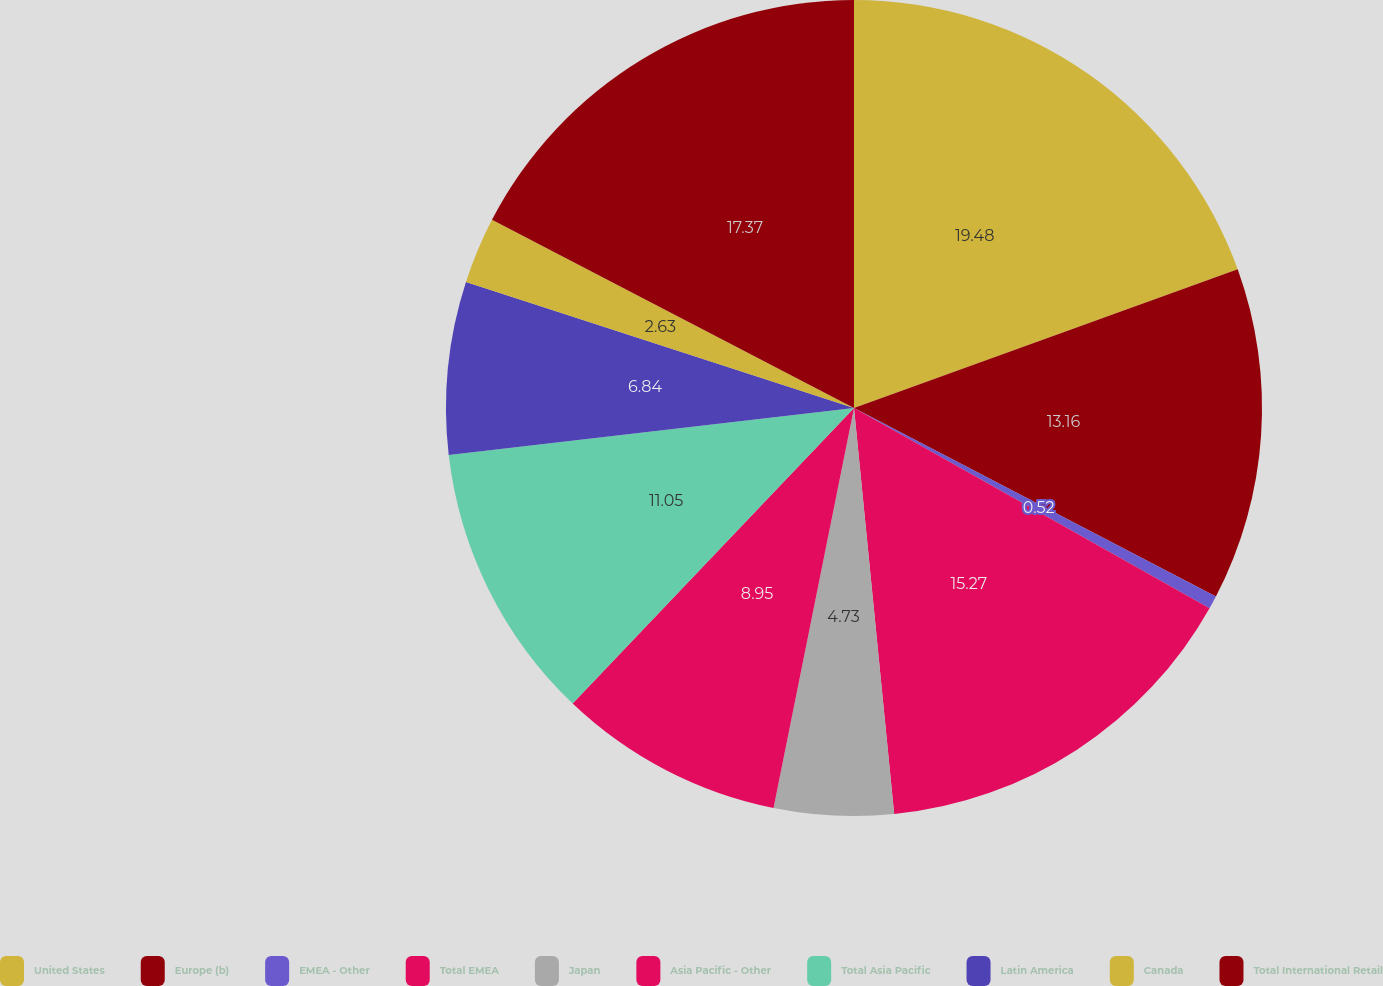Convert chart. <chart><loc_0><loc_0><loc_500><loc_500><pie_chart><fcel>United States<fcel>Europe (b)<fcel>EMEA - Other<fcel>Total EMEA<fcel>Japan<fcel>Asia Pacific - Other<fcel>Total Asia Pacific<fcel>Latin America<fcel>Canada<fcel>Total International Retail<nl><fcel>19.48%<fcel>13.16%<fcel>0.52%<fcel>15.27%<fcel>4.73%<fcel>8.95%<fcel>11.05%<fcel>6.84%<fcel>2.63%<fcel>17.37%<nl></chart> 